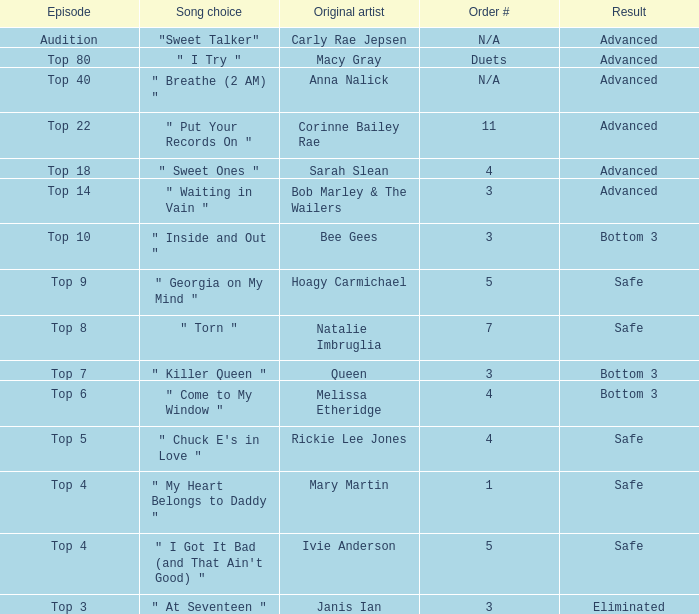What was the conclusion of the top 3 episode? Eliminated. 